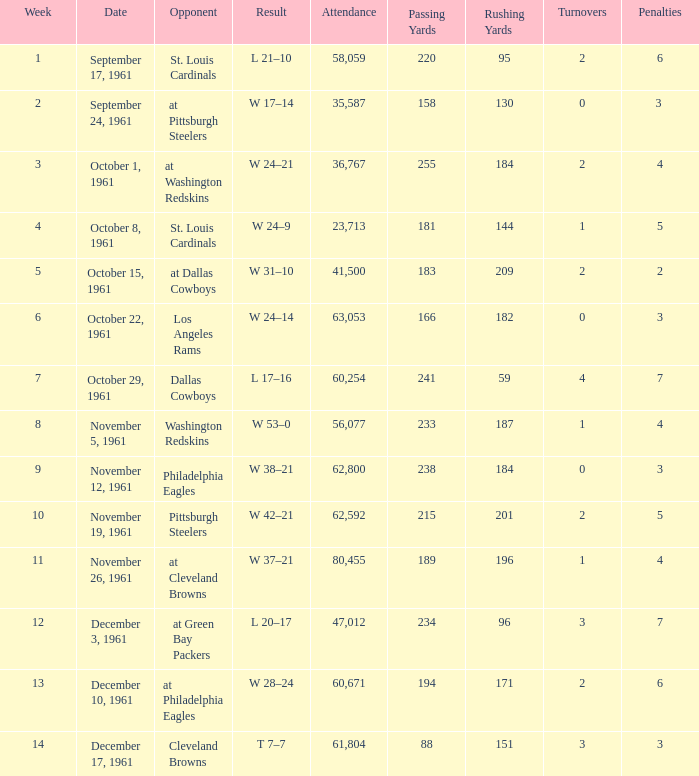Which presence has a date of november 19, 1961? 62592.0. 